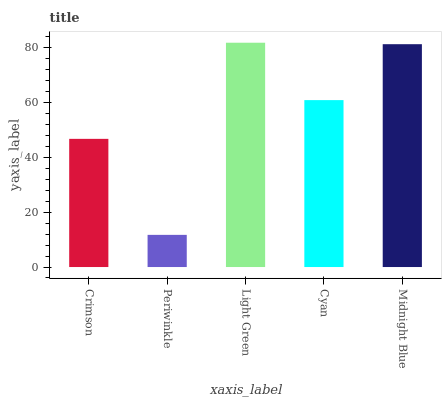Is Periwinkle the minimum?
Answer yes or no. Yes. Is Light Green the maximum?
Answer yes or no. Yes. Is Light Green the minimum?
Answer yes or no. No. Is Periwinkle the maximum?
Answer yes or no. No. Is Light Green greater than Periwinkle?
Answer yes or no. Yes. Is Periwinkle less than Light Green?
Answer yes or no. Yes. Is Periwinkle greater than Light Green?
Answer yes or no. No. Is Light Green less than Periwinkle?
Answer yes or no. No. Is Cyan the high median?
Answer yes or no. Yes. Is Cyan the low median?
Answer yes or no. Yes. Is Crimson the high median?
Answer yes or no. No. Is Periwinkle the low median?
Answer yes or no. No. 